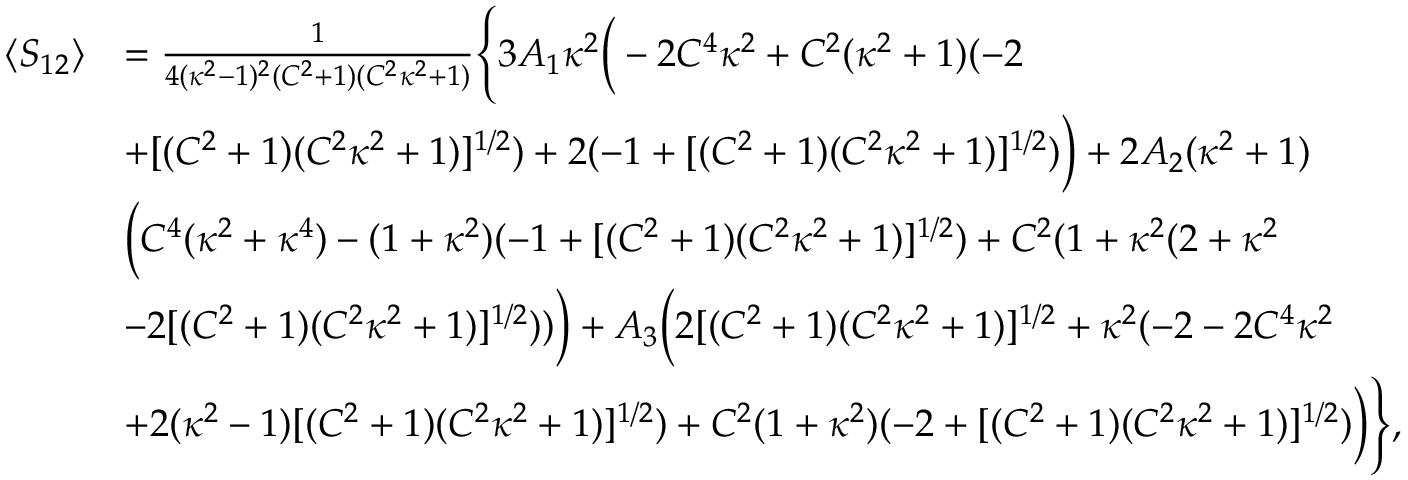<formula> <loc_0><loc_0><loc_500><loc_500>\begin{array} { r l } { \langle S _ { 1 2 } \rangle } & { = \frac { 1 } { 4 ( \kappa ^ { 2 } - 1 ) ^ { 2 } ( C ^ { 2 } + 1 ) ( C ^ { 2 } \kappa ^ { 2 } + 1 ) } \left \{ 3 A _ { 1 } \kappa ^ { 2 } \left ( - 2 C ^ { 4 } \kappa ^ { 2 } + C ^ { 2 } ( \kappa ^ { 2 } + 1 ) ( - 2 } \\ & { + [ ( C ^ { 2 } + 1 ) ( C ^ { 2 } \kappa ^ { 2 } + 1 ) ] ^ { 1 / 2 } ) + 2 ( - 1 + [ ( C ^ { 2 } + 1 ) ( C ^ { 2 } \kappa ^ { 2 } + 1 ) ] ^ { 1 / 2 } ) \right ) + 2 A _ { 2 } ( \kappa ^ { 2 } + 1 ) } \\ & { \left ( C ^ { 4 } ( \kappa ^ { 2 } + \kappa ^ { 4 } ) - ( 1 + \kappa ^ { 2 } ) ( - 1 + [ ( C ^ { 2 } + 1 ) ( C ^ { 2 } \kappa ^ { 2 } + 1 ) ] ^ { 1 / 2 } ) + C ^ { 2 } ( 1 + \kappa ^ { 2 } ( 2 + \kappa ^ { 2 } } \\ & { - 2 [ ( C ^ { 2 } + 1 ) ( C ^ { 2 } \kappa ^ { 2 } + 1 ) ] ^ { 1 / 2 } ) ) \right ) + A _ { 3 } \left ( 2 [ ( C ^ { 2 } + 1 ) ( C ^ { 2 } \kappa ^ { 2 } + 1 ) ] ^ { 1 / 2 } + \kappa ^ { 2 } ( - 2 - 2 C ^ { 4 } \kappa ^ { 2 } } \\ & { + 2 ( \kappa ^ { 2 } - 1 ) [ ( C ^ { 2 } + 1 ) ( C ^ { 2 } \kappa ^ { 2 } + 1 ) ] ^ { 1 / 2 } ) + C ^ { 2 } ( 1 + \kappa ^ { 2 } ) ( - 2 + [ ( C ^ { 2 } + 1 ) ( C ^ { 2 } \kappa ^ { 2 } + 1 ) ] ^ { 1 / 2 } ) \right ) \right \} , } \end{array}</formula> 